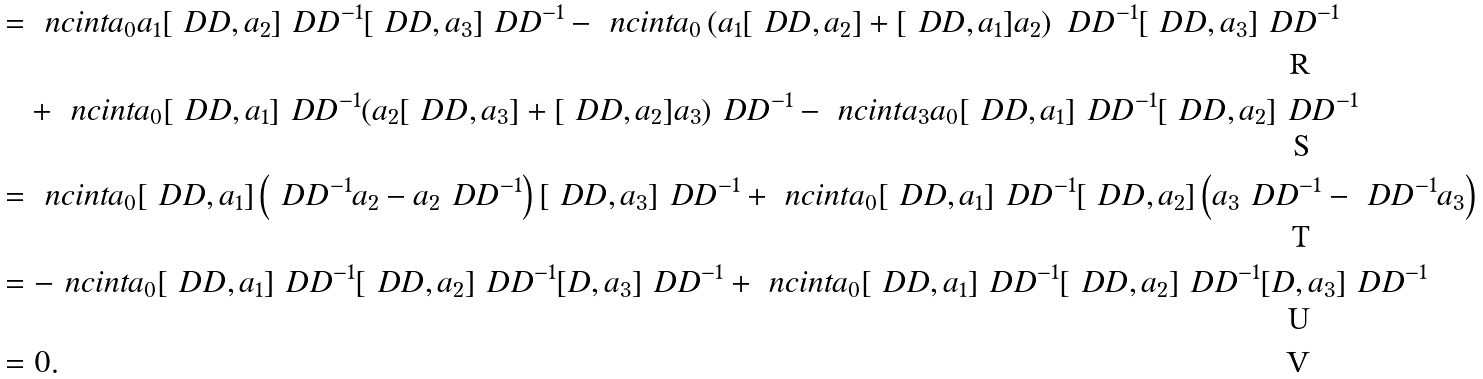<formula> <loc_0><loc_0><loc_500><loc_500>& = \ n c i n t a _ { 0 } a _ { 1 } [ \ D D , a _ { 2 } ] \ D D ^ { - 1 } [ \ D D , a _ { 3 } ] \ D D ^ { - 1 } - \ n c i n t a _ { 0 } \left ( a _ { 1 } [ \ D D , a _ { 2 } ] + [ \ D D , a _ { 1 } ] a _ { 2 } \right ) \ D D ^ { - 1 } [ \ D D , a _ { 3 } ] \ D D ^ { - 1 } \\ & \quad + \ n c i n t a _ { 0 } [ \ D D , a _ { 1 } ] \ D D ^ { - 1 } ( a _ { 2 } [ \ D D , a _ { 3 } ] + [ \ D D , a _ { 2 } ] a _ { 3 } ) \ D D ^ { - 1 } - \ n c i n t a _ { 3 } a _ { 0 } [ \ D D , a _ { 1 } ] \ D D ^ { - 1 } [ \ D D , a _ { 2 } ] \ D D ^ { - 1 } \\ & = \ n c i n t a _ { 0 } [ \ D D , a _ { 1 } ] \left ( \ D D ^ { - 1 } a _ { 2 } - a _ { 2 } \ D D ^ { - 1 } \right ) [ \ D D , a _ { 3 } ] \ D D ^ { - 1 } + \ n c i n t a _ { 0 } [ \ D D , a _ { 1 } ] \ D D ^ { - 1 } [ \ D D , a _ { 2 } ] \left ( a _ { 3 } \ D D ^ { - 1 } - \ D D ^ { - 1 } a _ { 3 } \right ) \\ & = - \ n c i n t a _ { 0 } [ \ D D , a _ { 1 } ] \ D D ^ { - 1 } [ \ D D , a _ { 2 } ] \ D D ^ { - 1 } [ D , a _ { 3 } ] \ D D ^ { - 1 } + \ n c i n t a _ { 0 } [ \ D D , a _ { 1 } ] \ D D ^ { - 1 } [ \ D D , a _ { 2 } ] \ D D ^ { - 1 } [ D , a _ { 3 } ] \ D D ^ { - 1 } \\ & = 0 .</formula> 